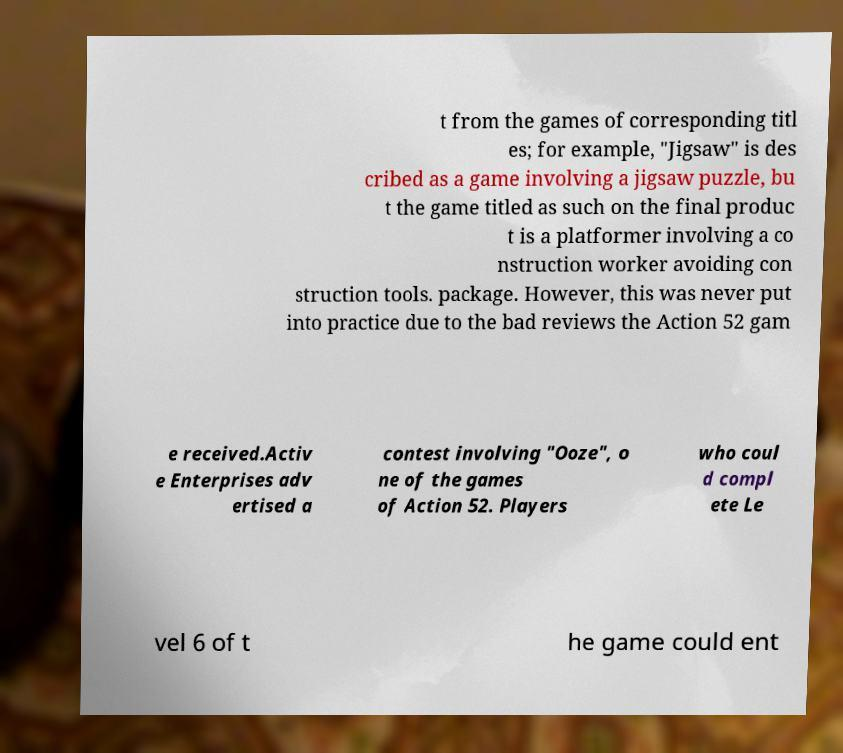Could you assist in decoding the text presented in this image and type it out clearly? t from the games of corresponding titl es; for example, "Jigsaw" is des cribed as a game involving a jigsaw puzzle, bu t the game titled as such on the final produc t is a platformer involving a co nstruction worker avoiding con struction tools. package. However, this was never put into practice due to the bad reviews the Action 52 gam e received.Activ e Enterprises adv ertised a contest involving "Ooze", o ne of the games of Action 52. Players who coul d compl ete Le vel 6 of t he game could ent 